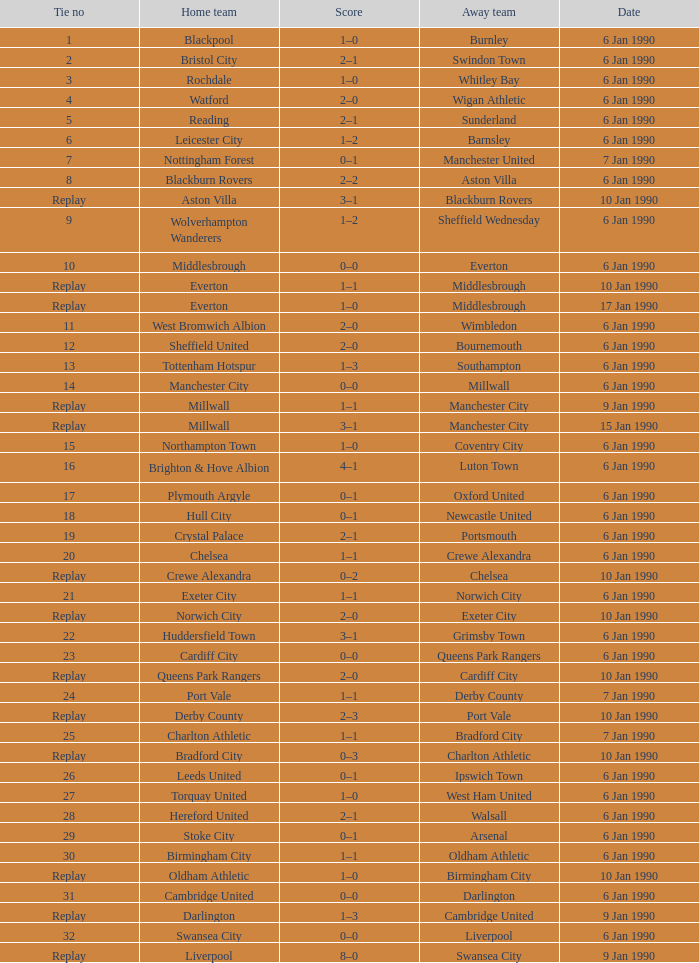What was the score of the game against away team crewe alexandra? 1–1. 